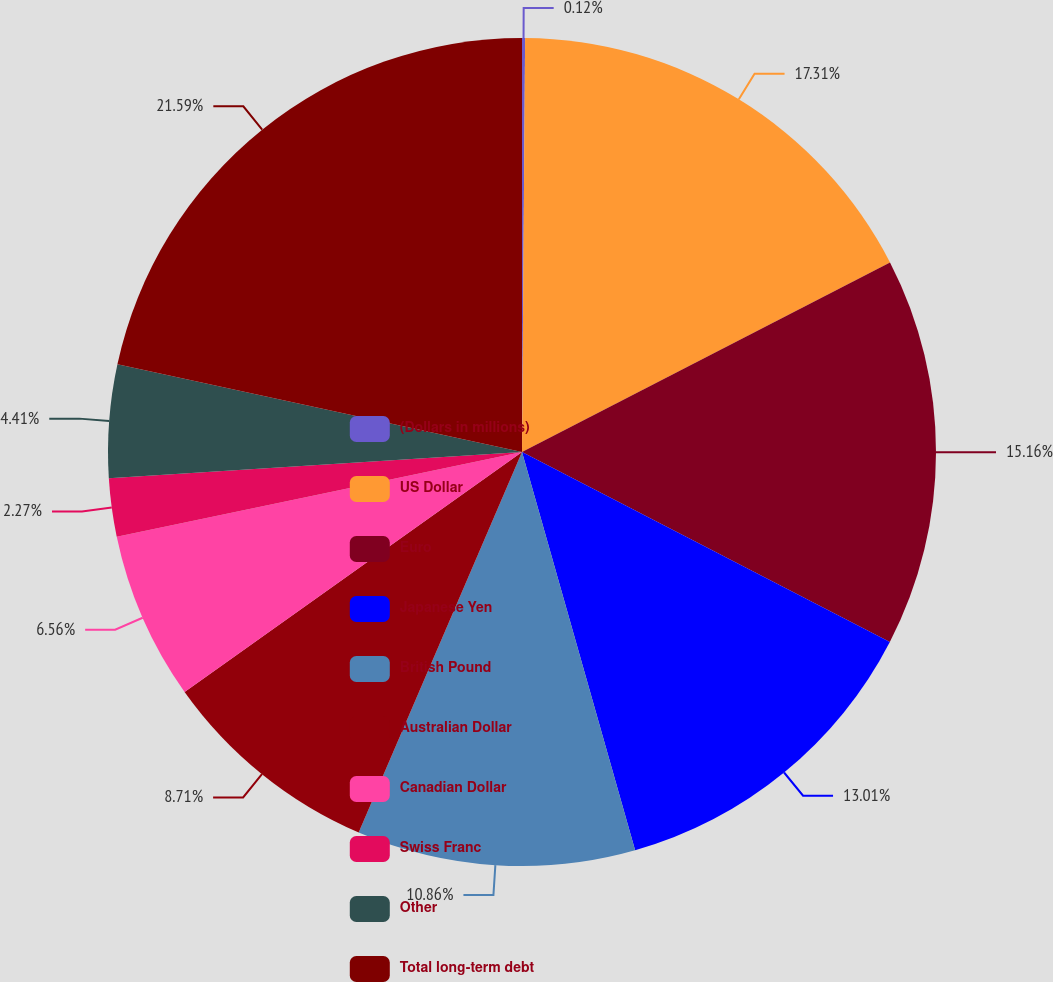<chart> <loc_0><loc_0><loc_500><loc_500><pie_chart><fcel>(Dollars in millions)<fcel>US Dollar<fcel>Euro<fcel>Japanese Yen<fcel>British Pound<fcel>Australian Dollar<fcel>Canadian Dollar<fcel>Swiss Franc<fcel>Other<fcel>Total long-term debt<nl><fcel>0.12%<fcel>17.31%<fcel>15.16%<fcel>13.01%<fcel>10.86%<fcel>8.71%<fcel>6.56%<fcel>2.27%<fcel>4.41%<fcel>21.6%<nl></chart> 